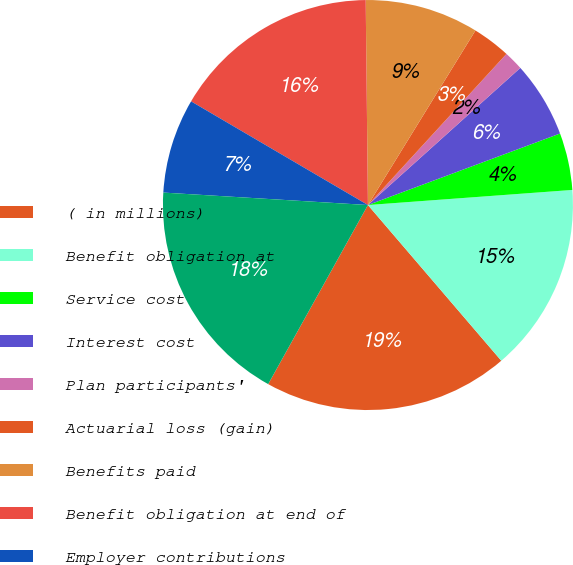Convert chart to OTSL. <chart><loc_0><loc_0><loc_500><loc_500><pie_chart><fcel>( in millions)<fcel>Benefit obligation at<fcel>Service cost<fcel>Interest cost<fcel>Plan participants'<fcel>Actuarial loss (gain)<fcel>Benefits paid<fcel>Benefit obligation at end of<fcel>Employer contributions<fcel>Funded status<nl><fcel>19.36%<fcel>14.9%<fcel>4.5%<fcel>5.99%<fcel>1.53%<fcel>3.02%<fcel>8.96%<fcel>16.39%<fcel>7.47%<fcel>17.88%<nl></chart> 